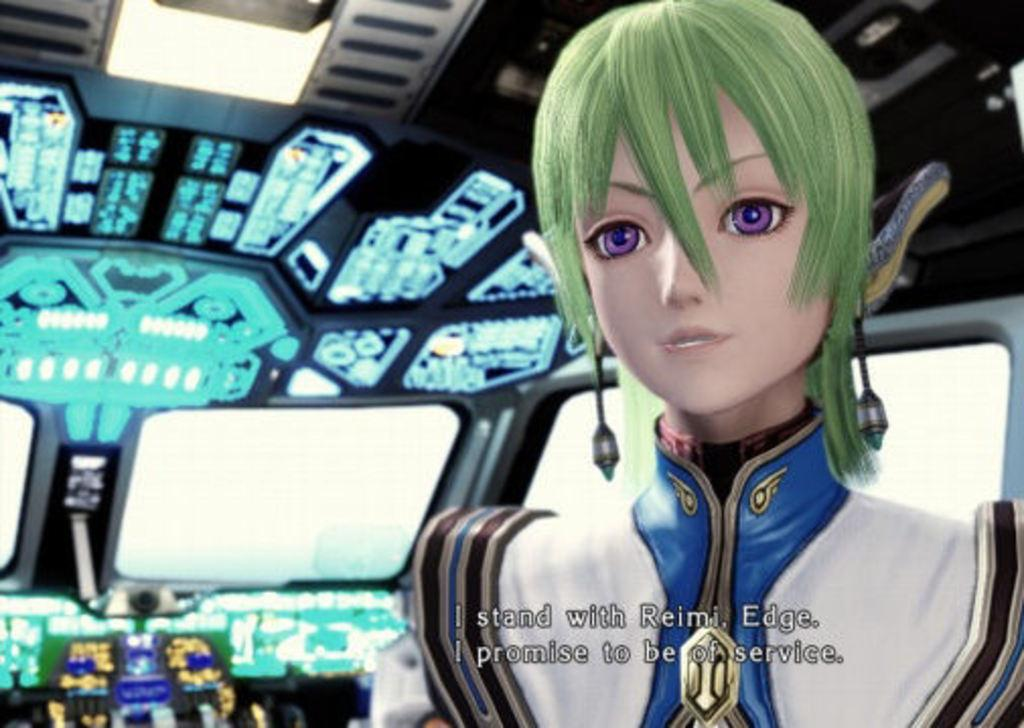<image>
Describe the image concisely. a cartoon person who refers to Reimi is on a ship of some sort 